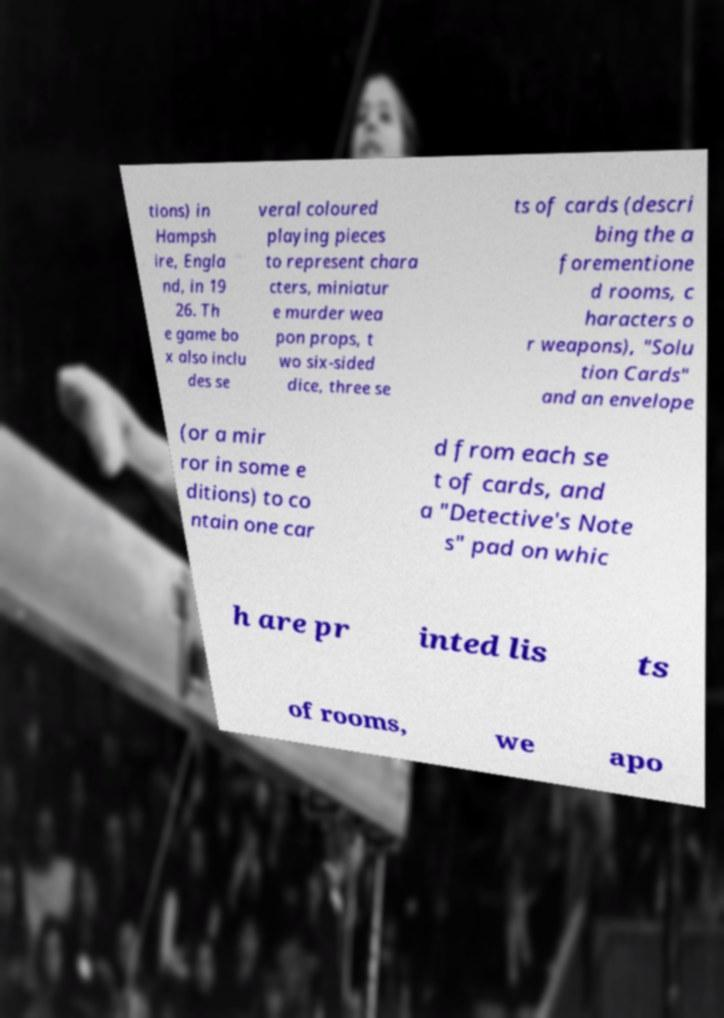Can you read and provide the text displayed in the image?This photo seems to have some interesting text. Can you extract and type it out for me? tions) in Hampsh ire, Engla nd, in 19 26. Th e game bo x also inclu des se veral coloured playing pieces to represent chara cters, miniatur e murder wea pon props, t wo six-sided dice, three se ts of cards (descri bing the a forementione d rooms, c haracters o r weapons), "Solu tion Cards" and an envelope (or a mir ror in some e ditions) to co ntain one car d from each se t of cards, and a "Detective's Note s" pad on whic h are pr inted lis ts of rooms, we apo 